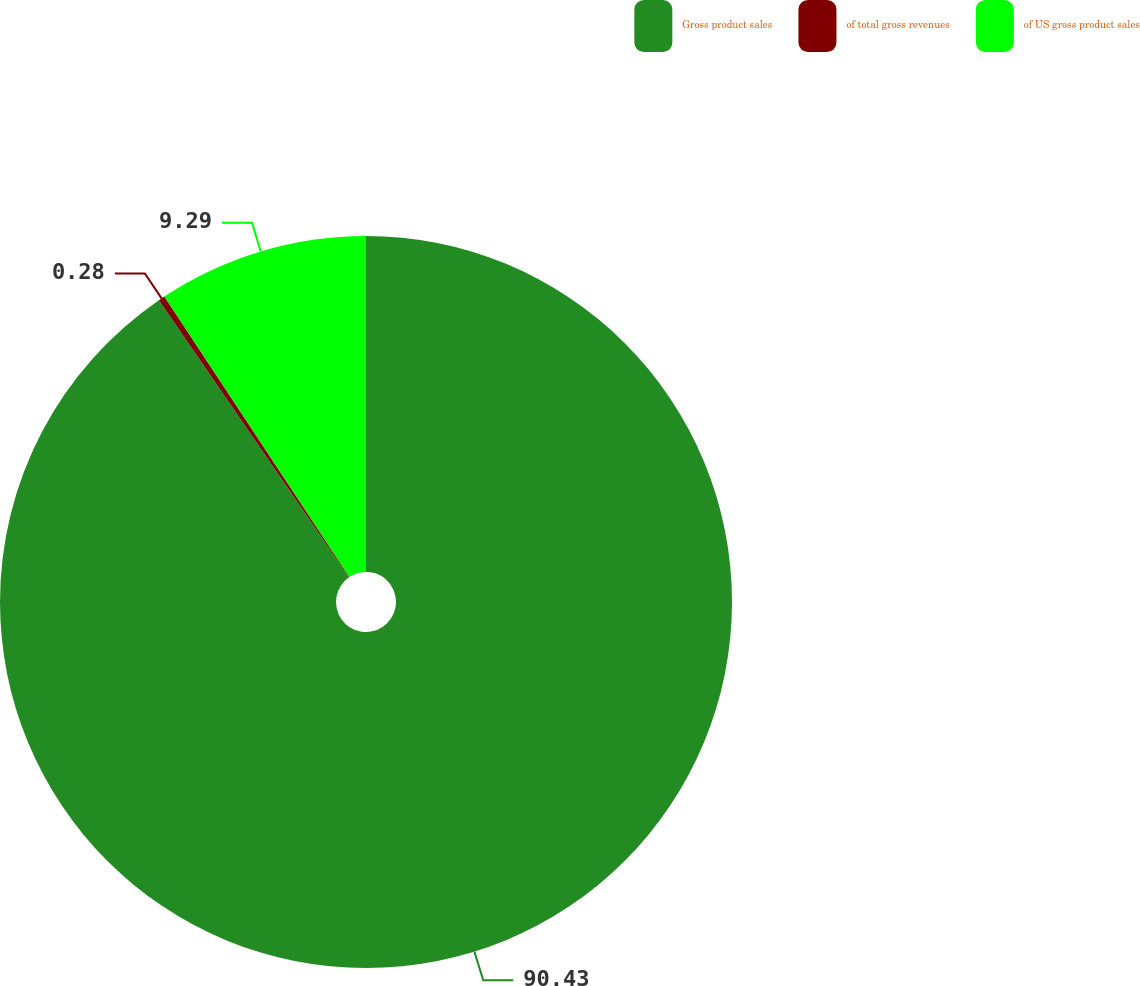<chart> <loc_0><loc_0><loc_500><loc_500><pie_chart><fcel>Gross product sales<fcel>of total gross revenues<fcel>of US gross product sales<nl><fcel>90.43%<fcel>0.28%<fcel>9.29%<nl></chart> 